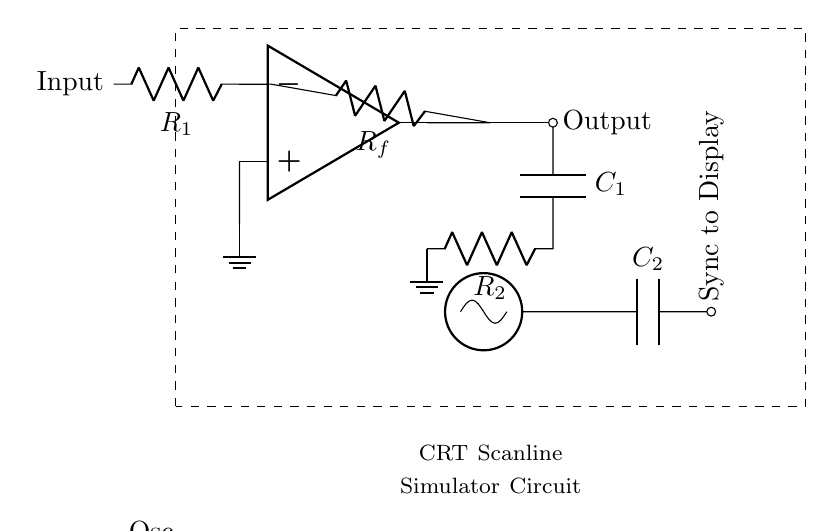What is the primary component used to amplify the signal in this circuit? The op-amp, located at the left side of the diagram, is the primary component responsible for signal amplification in this circuit.
Answer: op-amp How many resistors are present in the circuit? The circuit features two resistors, labeled as R1 and R2, located along the amplification and filtering paths respectively.
Answer: 2 What does C1 do in this circuit? C1, connected below the output node, serves as a capacitor to filter and smoothen the output signal, contributing to simulating the desired scanline effect.
Answer: capacitor What component is used to synchronize with the display? The circuit includes an oscillator that generates a timing signal for synchronization, which is clearly labeled and positioned near the midpoint on the right.
Answer: oscillator What is the connection type used between the op-amp output and Rf? The connection is made via a short wire (indicated as a straight line) that links the op-amp output to the resistor Rf, signifying a direct electrical connection.
Answer: short What effect does the combination of C2 and the oscillator have on the circuit? C2, in combination with the oscillator, helps to define the timing of the scanline simulation based on the frequency generated by the oscillator, thus affecting the scanline appearance on the display.
Answer: timing What is the purpose of the dashed rectangle surrounding the circuit? The dashed rectangle is a visual aid indicating the boundary of the CRT scanline simulator circuit, which helps to encapsulate the components that are part of this specific function.
Answer: boundary 